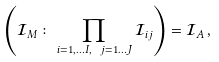<formula> <loc_0><loc_0><loc_500><loc_500>\left ( { \mathcal { I } } _ { M } \colon \prod _ { i = 1 , \dots I , \ j = 1 \dots J } { \mathcal { I } } _ { i j } \right ) = { \mathcal { I } } _ { A } \, ,</formula> 